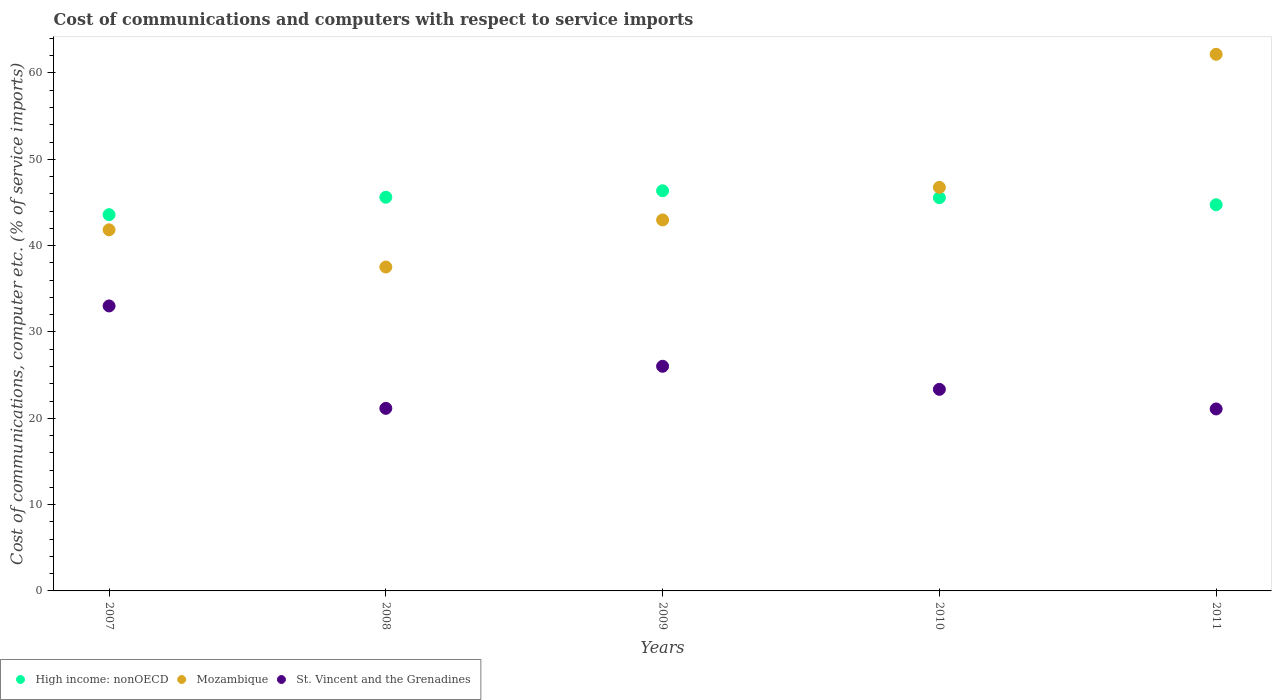How many different coloured dotlines are there?
Provide a succinct answer. 3. What is the cost of communications and computers in Mozambique in 2009?
Ensure brevity in your answer.  42.98. Across all years, what is the maximum cost of communications and computers in St. Vincent and the Grenadines?
Your answer should be compact. 33.01. Across all years, what is the minimum cost of communications and computers in High income: nonOECD?
Give a very brief answer. 43.59. In which year was the cost of communications and computers in St. Vincent and the Grenadines minimum?
Provide a short and direct response. 2011. What is the total cost of communications and computers in High income: nonOECD in the graph?
Keep it short and to the point. 225.84. What is the difference between the cost of communications and computers in St. Vincent and the Grenadines in 2009 and that in 2011?
Keep it short and to the point. 4.94. What is the difference between the cost of communications and computers in St. Vincent and the Grenadines in 2008 and the cost of communications and computers in High income: nonOECD in 2009?
Keep it short and to the point. -25.2. What is the average cost of communications and computers in Mozambique per year?
Offer a terse response. 46.25. In the year 2010, what is the difference between the cost of communications and computers in Mozambique and cost of communications and computers in St. Vincent and the Grenadines?
Provide a short and direct response. 23.4. What is the ratio of the cost of communications and computers in Mozambique in 2007 to that in 2008?
Your response must be concise. 1.11. Is the cost of communications and computers in Mozambique in 2007 less than that in 2010?
Your answer should be compact. Yes. What is the difference between the highest and the second highest cost of communications and computers in High income: nonOECD?
Your response must be concise. 0.75. What is the difference between the highest and the lowest cost of communications and computers in St. Vincent and the Grenadines?
Offer a very short reply. 11.93. Is the sum of the cost of communications and computers in St. Vincent and the Grenadines in 2007 and 2011 greater than the maximum cost of communications and computers in High income: nonOECD across all years?
Provide a succinct answer. Yes. Does the cost of communications and computers in St. Vincent and the Grenadines monotonically increase over the years?
Provide a succinct answer. No. How many dotlines are there?
Offer a very short reply. 3. What is the difference between two consecutive major ticks on the Y-axis?
Your answer should be very brief. 10. Does the graph contain any zero values?
Provide a succinct answer. No. Does the graph contain grids?
Ensure brevity in your answer.  No. How are the legend labels stacked?
Make the answer very short. Horizontal. What is the title of the graph?
Your answer should be compact. Cost of communications and computers with respect to service imports. What is the label or title of the Y-axis?
Your answer should be compact. Cost of communications, computer etc. (% of service imports). What is the Cost of communications, computer etc. (% of service imports) in High income: nonOECD in 2007?
Your response must be concise. 43.59. What is the Cost of communications, computer etc. (% of service imports) in Mozambique in 2007?
Offer a very short reply. 41.83. What is the Cost of communications, computer etc. (% of service imports) in St. Vincent and the Grenadines in 2007?
Provide a short and direct response. 33.01. What is the Cost of communications, computer etc. (% of service imports) in High income: nonOECD in 2008?
Make the answer very short. 45.61. What is the Cost of communications, computer etc. (% of service imports) in Mozambique in 2008?
Offer a very short reply. 37.52. What is the Cost of communications, computer etc. (% of service imports) of St. Vincent and the Grenadines in 2008?
Ensure brevity in your answer.  21.15. What is the Cost of communications, computer etc. (% of service imports) of High income: nonOECD in 2009?
Give a very brief answer. 46.35. What is the Cost of communications, computer etc. (% of service imports) in Mozambique in 2009?
Keep it short and to the point. 42.98. What is the Cost of communications, computer etc. (% of service imports) of St. Vincent and the Grenadines in 2009?
Provide a short and direct response. 26.02. What is the Cost of communications, computer etc. (% of service imports) of High income: nonOECD in 2010?
Your response must be concise. 45.55. What is the Cost of communications, computer etc. (% of service imports) in Mozambique in 2010?
Offer a terse response. 46.75. What is the Cost of communications, computer etc. (% of service imports) in St. Vincent and the Grenadines in 2010?
Offer a very short reply. 23.35. What is the Cost of communications, computer etc. (% of service imports) of High income: nonOECD in 2011?
Keep it short and to the point. 44.74. What is the Cost of communications, computer etc. (% of service imports) of Mozambique in 2011?
Your response must be concise. 62.16. What is the Cost of communications, computer etc. (% of service imports) in St. Vincent and the Grenadines in 2011?
Keep it short and to the point. 21.08. Across all years, what is the maximum Cost of communications, computer etc. (% of service imports) of High income: nonOECD?
Make the answer very short. 46.35. Across all years, what is the maximum Cost of communications, computer etc. (% of service imports) of Mozambique?
Your answer should be very brief. 62.16. Across all years, what is the maximum Cost of communications, computer etc. (% of service imports) in St. Vincent and the Grenadines?
Ensure brevity in your answer.  33.01. Across all years, what is the minimum Cost of communications, computer etc. (% of service imports) in High income: nonOECD?
Ensure brevity in your answer.  43.59. Across all years, what is the minimum Cost of communications, computer etc. (% of service imports) in Mozambique?
Make the answer very short. 37.52. Across all years, what is the minimum Cost of communications, computer etc. (% of service imports) in St. Vincent and the Grenadines?
Offer a terse response. 21.08. What is the total Cost of communications, computer etc. (% of service imports) in High income: nonOECD in the graph?
Provide a succinct answer. 225.84. What is the total Cost of communications, computer etc. (% of service imports) of Mozambique in the graph?
Your response must be concise. 231.24. What is the total Cost of communications, computer etc. (% of service imports) in St. Vincent and the Grenadines in the graph?
Provide a succinct answer. 124.62. What is the difference between the Cost of communications, computer etc. (% of service imports) of High income: nonOECD in 2007 and that in 2008?
Make the answer very short. -2.02. What is the difference between the Cost of communications, computer etc. (% of service imports) in Mozambique in 2007 and that in 2008?
Provide a succinct answer. 4.31. What is the difference between the Cost of communications, computer etc. (% of service imports) of St. Vincent and the Grenadines in 2007 and that in 2008?
Your response must be concise. 11.86. What is the difference between the Cost of communications, computer etc. (% of service imports) in High income: nonOECD in 2007 and that in 2009?
Your response must be concise. -2.77. What is the difference between the Cost of communications, computer etc. (% of service imports) of Mozambique in 2007 and that in 2009?
Keep it short and to the point. -1.14. What is the difference between the Cost of communications, computer etc. (% of service imports) of St. Vincent and the Grenadines in 2007 and that in 2009?
Ensure brevity in your answer.  6.99. What is the difference between the Cost of communications, computer etc. (% of service imports) of High income: nonOECD in 2007 and that in 2010?
Provide a succinct answer. -1.97. What is the difference between the Cost of communications, computer etc. (% of service imports) of Mozambique in 2007 and that in 2010?
Offer a terse response. -4.92. What is the difference between the Cost of communications, computer etc. (% of service imports) in St. Vincent and the Grenadines in 2007 and that in 2010?
Your answer should be compact. 9.66. What is the difference between the Cost of communications, computer etc. (% of service imports) in High income: nonOECD in 2007 and that in 2011?
Your answer should be very brief. -1.15. What is the difference between the Cost of communications, computer etc. (% of service imports) in Mozambique in 2007 and that in 2011?
Provide a short and direct response. -20.33. What is the difference between the Cost of communications, computer etc. (% of service imports) of St. Vincent and the Grenadines in 2007 and that in 2011?
Your response must be concise. 11.93. What is the difference between the Cost of communications, computer etc. (% of service imports) in High income: nonOECD in 2008 and that in 2009?
Give a very brief answer. -0.75. What is the difference between the Cost of communications, computer etc. (% of service imports) in Mozambique in 2008 and that in 2009?
Provide a succinct answer. -5.45. What is the difference between the Cost of communications, computer etc. (% of service imports) of St. Vincent and the Grenadines in 2008 and that in 2009?
Keep it short and to the point. -4.87. What is the difference between the Cost of communications, computer etc. (% of service imports) of High income: nonOECD in 2008 and that in 2010?
Ensure brevity in your answer.  0.05. What is the difference between the Cost of communications, computer etc. (% of service imports) of Mozambique in 2008 and that in 2010?
Provide a succinct answer. -9.23. What is the difference between the Cost of communications, computer etc. (% of service imports) in St. Vincent and the Grenadines in 2008 and that in 2010?
Ensure brevity in your answer.  -2.2. What is the difference between the Cost of communications, computer etc. (% of service imports) of High income: nonOECD in 2008 and that in 2011?
Offer a terse response. 0.87. What is the difference between the Cost of communications, computer etc. (% of service imports) of Mozambique in 2008 and that in 2011?
Offer a very short reply. -24.64. What is the difference between the Cost of communications, computer etc. (% of service imports) in St. Vincent and the Grenadines in 2008 and that in 2011?
Ensure brevity in your answer.  0.07. What is the difference between the Cost of communications, computer etc. (% of service imports) of High income: nonOECD in 2009 and that in 2010?
Provide a short and direct response. 0.8. What is the difference between the Cost of communications, computer etc. (% of service imports) in Mozambique in 2009 and that in 2010?
Offer a terse response. -3.77. What is the difference between the Cost of communications, computer etc. (% of service imports) of St. Vincent and the Grenadines in 2009 and that in 2010?
Offer a terse response. 2.67. What is the difference between the Cost of communications, computer etc. (% of service imports) of High income: nonOECD in 2009 and that in 2011?
Offer a terse response. 1.62. What is the difference between the Cost of communications, computer etc. (% of service imports) of Mozambique in 2009 and that in 2011?
Your answer should be very brief. -19.19. What is the difference between the Cost of communications, computer etc. (% of service imports) of St. Vincent and the Grenadines in 2009 and that in 2011?
Keep it short and to the point. 4.94. What is the difference between the Cost of communications, computer etc. (% of service imports) of High income: nonOECD in 2010 and that in 2011?
Offer a very short reply. 0.82. What is the difference between the Cost of communications, computer etc. (% of service imports) in Mozambique in 2010 and that in 2011?
Give a very brief answer. -15.41. What is the difference between the Cost of communications, computer etc. (% of service imports) in St. Vincent and the Grenadines in 2010 and that in 2011?
Give a very brief answer. 2.27. What is the difference between the Cost of communications, computer etc. (% of service imports) in High income: nonOECD in 2007 and the Cost of communications, computer etc. (% of service imports) in Mozambique in 2008?
Provide a succinct answer. 6.06. What is the difference between the Cost of communications, computer etc. (% of service imports) in High income: nonOECD in 2007 and the Cost of communications, computer etc. (% of service imports) in St. Vincent and the Grenadines in 2008?
Provide a succinct answer. 22.44. What is the difference between the Cost of communications, computer etc. (% of service imports) of Mozambique in 2007 and the Cost of communications, computer etc. (% of service imports) of St. Vincent and the Grenadines in 2008?
Provide a short and direct response. 20.68. What is the difference between the Cost of communications, computer etc. (% of service imports) in High income: nonOECD in 2007 and the Cost of communications, computer etc. (% of service imports) in Mozambique in 2009?
Your answer should be compact. 0.61. What is the difference between the Cost of communications, computer etc. (% of service imports) of High income: nonOECD in 2007 and the Cost of communications, computer etc. (% of service imports) of St. Vincent and the Grenadines in 2009?
Ensure brevity in your answer.  17.56. What is the difference between the Cost of communications, computer etc. (% of service imports) of Mozambique in 2007 and the Cost of communications, computer etc. (% of service imports) of St. Vincent and the Grenadines in 2009?
Provide a short and direct response. 15.81. What is the difference between the Cost of communications, computer etc. (% of service imports) of High income: nonOECD in 2007 and the Cost of communications, computer etc. (% of service imports) of Mozambique in 2010?
Keep it short and to the point. -3.16. What is the difference between the Cost of communications, computer etc. (% of service imports) in High income: nonOECD in 2007 and the Cost of communications, computer etc. (% of service imports) in St. Vincent and the Grenadines in 2010?
Keep it short and to the point. 20.23. What is the difference between the Cost of communications, computer etc. (% of service imports) in Mozambique in 2007 and the Cost of communications, computer etc. (% of service imports) in St. Vincent and the Grenadines in 2010?
Provide a short and direct response. 18.48. What is the difference between the Cost of communications, computer etc. (% of service imports) of High income: nonOECD in 2007 and the Cost of communications, computer etc. (% of service imports) of Mozambique in 2011?
Provide a short and direct response. -18.58. What is the difference between the Cost of communications, computer etc. (% of service imports) of High income: nonOECD in 2007 and the Cost of communications, computer etc. (% of service imports) of St. Vincent and the Grenadines in 2011?
Give a very brief answer. 22.5. What is the difference between the Cost of communications, computer etc. (% of service imports) in Mozambique in 2007 and the Cost of communications, computer etc. (% of service imports) in St. Vincent and the Grenadines in 2011?
Your response must be concise. 20.75. What is the difference between the Cost of communications, computer etc. (% of service imports) in High income: nonOECD in 2008 and the Cost of communications, computer etc. (% of service imports) in Mozambique in 2009?
Give a very brief answer. 2.63. What is the difference between the Cost of communications, computer etc. (% of service imports) of High income: nonOECD in 2008 and the Cost of communications, computer etc. (% of service imports) of St. Vincent and the Grenadines in 2009?
Ensure brevity in your answer.  19.58. What is the difference between the Cost of communications, computer etc. (% of service imports) of Mozambique in 2008 and the Cost of communications, computer etc. (% of service imports) of St. Vincent and the Grenadines in 2009?
Provide a short and direct response. 11.5. What is the difference between the Cost of communications, computer etc. (% of service imports) of High income: nonOECD in 2008 and the Cost of communications, computer etc. (% of service imports) of Mozambique in 2010?
Give a very brief answer. -1.14. What is the difference between the Cost of communications, computer etc. (% of service imports) of High income: nonOECD in 2008 and the Cost of communications, computer etc. (% of service imports) of St. Vincent and the Grenadines in 2010?
Ensure brevity in your answer.  22.25. What is the difference between the Cost of communications, computer etc. (% of service imports) of Mozambique in 2008 and the Cost of communications, computer etc. (% of service imports) of St. Vincent and the Grenadines in 2010?
Your answer should be compact. 14.17. What is the difference between the Cost of communications, computer etc. (% of service imports) of High income: nonOECD in 2008 and the Cost of communications, computer etc. (% of service imports) of Mozambique in 2011?
Your answer should be very brief. -16.56. What is the difference between the Cost of communications, computer etc. (% of service imports) in High income: nonOECD in 2008 and the Cost of communications, computer etc. (% of service imports) in St. Vincent and the Grenadines in 2011?
Give a very brief answer. 24.52. What is the difference between the Cost of communications, computer etc. (% of service imports) of Mozambique in 2008 and the Cost of communications, computer etc. (% of service imports) of St. Vincent and the Grenadines in 2011?
Your answer should be compact. 16.44. What is the difference between the Cost of communications, computer etc. (% of service imports) in High income: nonOECD in 2009 and the Cost of communications, computer etc. (% of service imports) in Mozambique in 2010?
Provide a succinct answer. -0.4. What is the difference between the Cost of communications, computer etc. (% of service imports) in High income: nonOECD in 2009 and the Cost of communications, computer etc. (% of service imports) in St. Vincent and the Grenadines in 2010?
Offer a very short reply. 23. What is the difference between the Cost of communications, computer etc. (% of service imports) of Mozambique in 2009 and the Cost of communications, computer etc. (% of service imports) of St. Vincent and the Grenadines in 2010?
Offer a very short reply. 19.62. What is the difference between the Cost of communications, computer etc. (% of service imports) of High income: nonOECD in 2009 and the Cost of communications, computer etc. (% of service imports) of Mozambique in 2011?
Ensure brevity in your answer.  -15.81. What is the difference between the Cost of communications, computer etc. (% of service imports) in High income: nonOECD in 2009 and the Cost of communications, computer etc. (% of service imports) in St. Vincent and the Grenadines in 2011?
Ensure brevity in your answer.  25.27. What is the difference between the Cost of communications, computer etc. (% of service imports) of Mozambique in 2009 and the Cost of communications, computer etc. (% of service imports) of St. Vincent and the Grenadines in 2011?
Give a very brief answer. 21.89. What is the difference between the Cost of communications, computer etc. (% of service imports) of High income: nonOECD in 2010 and the Cost of communications, computer etc. (% of service imports) of Mozambique in 2011?
Give a very brief answer. -16.61. What is the difference between the Cost of communications, computer etc. (% of service imports) in High income: nonOECD in 2010 and the Cost of communications, computer etc. (% of service imports) in St. Vincent and the Grenadines in 2011?
Offer a terse response. 24.47. What is the difference between the Cost of communications, computer etc. (% of service imports) in Mozambique in 2010 and the Cost of communications, computer etc. (% of service imports) in St. Vincent and the Grenadines in 2011?
Your answer should be compact. 25.67. What is the average Cost of communications, computer etc. (% of service imports) of High income: nonOECD per year?
Make the answer very short. 45.17. What is the average Cost of communications, computer etc. (% of service imports) in Mozambique per year?
Give a very brief answer. 46.25. What is the average Cost of communications, computer etc. (% of service imports) in St. Vincent and the Grenadines per year?
Give a very brief answer. 24.92. In the year 2007, what is the difference between the Cost of communications, computer etc. (% of service imports) of High income: nonOECD and Cost of communications, computer etc. (% of service imports) of Mozambique?
Provide a short and direct response. 1.75. In the year 2007, what is the difference between the Cost of communications, computer etc. (% of service imports) of High income: nonOECD and Cost of communications, computer etc. (% of service imports) of St. Vincent and the Grenadines?
Your answer should be compact. 10.57. In the year 2007, what is the difference between the Cost of communications, computer etc. (% of service imports) in Mozambique and Cost of communications, computer etc. (% of service imports) in St. Vincent and the Grenadines?
Your answer should be very brief. 8.82. In the year 2008, what is the difference between the Cost of communications, computer etc. (% of service imports) in High income: nonOECD and Cost of communications, computer etc. (% of service imports) in Mozambique?
Provide a succinct answer. 8.08. In the year 2008, what is the difference between the Cost of communications, computer etc. (% of service imports) of High income: nonOECD and Cost of communications, computer etc. (% of service imports) of St. Vincent and the Grenadines?
Your response must be concise. 24.46. In the year 2008, what is the difference between the Cost of communications, computer etc. (% of service imports) of Mozambique and Cost of communications, computer etc. (% of service imports) of St. Vincent and the Grenadines?
Offer a very short reply. 16.37. In the year 2009, what is the difference between the Cost of communications, computer etc. (% of service imports) in High income: nonOECD and Cost of communications, computer etc. (% of service imports) in Mozambique?
Make the answer very short. 3.38. In the year 2009, what is the difference between the Cost of communications, computer etc. (% of service imports) in High income: nonOECD and Cost of communications, computer etc. (% of service imports) in St. Vincent and the Grenadines?
Offer a terse response. 20.33. In the year 2009, what is the difference between the Cost of communications, computer etc. (% of service imports) in Mozambique and Cost of communications, computer etc. (% of service imports) in St. Vincent and the Grenadines?
Make the answer very short. 16.95. In the year 2010, what is the difference between the Cost of communications, computer etc. (% of service imports) of High income: nonOECD and Cost of communications, computer etc. (% of service imports) of Mozambique?
Provide a succinct answer. -1.2. In the year 2010, what is the difference between the Cost of communications, computer etc. (% of service imports) of High income: nonOECD and Cost of communications, computer etc. (% of service imports) of St. Vincent and the Grenadines?
Provide a short and direct response. 22.2. In the year 2010, what is the difference between the Cost of communications, computer etc. (% of service imports) of Mozambique and Cost of communications, computer etc. (% of service imports) of St. Vincent and the Grenadines?
Your answer should be compact. 23.4. In the year 2011, what is the difference between the Cost of communications, computer etc. (% of service imports) in High income: nonOECD and Cost of communications, computer etc. (% of service imports) in Mozambique?
Your response must be concise. -17.43. In the year 2011, what is the difference between the Cost of communications, computer etc. (% of service imports) of High income: nonOECD and Cost of communications, computer etc. (% of service imports) of St. Vincent and the Grenadines?
Give a very brief answer. 23.66. In the year 2011, what is the difference between the Cost of communications, computer etc. (% of service imports) of Mozambique and Cost of communications, computer etc. (% of service imports) of St. Vincent and the Grenadines?
Your answer should be very brief. 41.08. What is the ratio of the Cost of communications, computer etc. (% of service imports) of High income: nonOECD in 2007 to that in 2008?
Provide a short and direct response. 0.96. What is the ratio of the Cost of communications, computer etc. (% of service imports) in Mozambique in 2007 to that in 2008?
Offer a very short reply. 1.11. What is the ratio of the Cost of communications, computer etc. (% of service imports) of St. Vincent and the Grenadines in 2007 to that in 2008?
Offer a very short reply. 1.56. What is the ratio of the Cost of communications, computer etc. (% of service imports) of High income: nonOECD in 2007 to that in 2009?
Give a very brief answer. 0.94. What is the ratio of the Cost of communications, computer etc. (% of service imports) of Mozambique in 2007 to that in 2009?
Offer a very short reply. 0.97. What is the ratio of the Cost of communications, computer etc. (% of service imports) in St. Vincent and the Grenadines in 2007 to that in 2009?
Keep it short and to the point. 1.27. What is the ratio of the Cost of communications, computer etc. (% of service imports) in High income: nonOECD in 2007 to that in 2010?
Your answer should be compact. 0.96. What is the ratio of the Cost of communications, computer etc. (% of service imports) of Mozambique in 2007 to that in 2010?
Your answer should be very brief. 0.89. What is the ratio of the Cost of communications, computer etc. (% of service imports) in St. Vincent and the Grenadines in 2007 to that in 2010?
Provide a short and direct response. 1.41. What is the ratio of the Cost of communications, computer etc. (% of service imports) of High income: nonOECD in 2007 to that in 2011?
Keep it short and to the point. 0.97. What is the ratio of the Cost of communications, computer etc. (% of service imports) of Mozambique in 2007 to that in 2011?
Make the answer very short. 0.67. What is the ratio of the Cost of communications, computer etc. (% of service imports) of St. Vincent and the Grenadines in 2007 to that in 2011?
Your answer should be very brief. 1.57. What is the ratio of the Cost of communications, computer etc. (% of service imports) of High income: nonOECD in 2008 to that in 2009?
Your answer should be compact. 0.98. What is the ratio of the Cost of communications, computer etc. (% of service imports) in Mozambique in 2008 to that in 2009?
Provide a short and direct response. 0.87. What is the ratio of the Cost of communications, computer etc. (% of service imports) of St. Vincent and the Grenadines in 2008 to that in 2009?
Give a very brief answer. 0.81. What is the ratio of the Cost of communications, computer etc. (% of service imports) in Mozambique in 2008 to that in 2010?
Give a very brief answer. 0.8. What is the ratio of the Cost of communications, computer etc. (% of service imports) of St. Vincent and the Grenadines in 2008 to that in 2010?
Offer a terse response. 0.91. What is the ratio of the Cost of communications, computer etc. (% of service imports) in High income: nonOECD in 2008 to that in 2011?
Your response must be concise. 1.02. What is the ratio of the Cost of communications, computer etc. (% of service imports) in Mozambique in 2008 to that in 2011?
Provide a short and direct response. 0.6. What is the ratio of the Cost of communications, computer etc. (% of service imports) in High income: nonOECD in 2009 to that in 2010?
Your answer should be very brief. 1.02. What is the ratio of the Cost of communications, computer etc. (% of service imports) in Mozambique in 2009 to that in 2010?
Give a very brief answer. 0.92. What is the ratio of the Cost of communications, computer etc. (% of service imports) of St. Vincent and the Grenadines in 2009 to that in 2010?
Your answer should be compact. 1.11. What is the ratio of the Cost of communications, computer etc. (% of service imports) of High income: nonOECD in 2009 to that in 2011?
Your answer should be compact. 1.04. What is the ratio of the Cost of communications, computer etc. (% of service imports) in Mozambique in 2009 to that in 2011?
Your response must be concise. 0.69. What is the ratio of the Cost of communications, computer etc. (% of service imports) in St. Vincent and the Grenadines in 2009 to that in 2011?
Provide a short and direct response. 1.23. What is the ratio of the Cost of communications, computer etc. (% of service imports) in High income: nonOECD in 2010 to that in 2011?
Keep it short and to the point. 1.02. What is the ratio of the Cost of communications, computer etc. (% of service imports) of Mozambique in 2010 to that in 2011?
Your response must be concise. 0.75. What is the ratio of the Cost of communications, computer etc. (% of service imports) in St. Vincent and the Grenadines in 2010 to that in 2011?
Offer a terse response. 1.11. What is the difference between the highest and the second highest Cost of communications, computer etc. (% of service imports) of High income: nonOECD?
Give a very brief answer. 0.75. What is the difference between the highest and the second highest Cost of communications, computer etc. (% of service imports) of Mozambique?
Ensure brevity in your answer.  15.41. What is the difference between the highest and the second highest Cost of communications, computer etc. (% of service imports) in St. Vincent and the Grenadines?
Provide a short and direct response. 6.99. What is the difference between the highest and the lowest Cost of communications, computer etc. (% of service imports) of High income: nonOECD?
Make the answer very short. 2.77. What is the difference between the highest and the lowest Cost of communications, computer etc. (% of service imports) in Mozambique?
Your answer should be very brief. 24.64. What is the difference between the highest and the lowest Cost of communications, computer etc. (% of service imports) in St. Vincent and the Grenadines?
Keep it short and to the point. 11.93. 